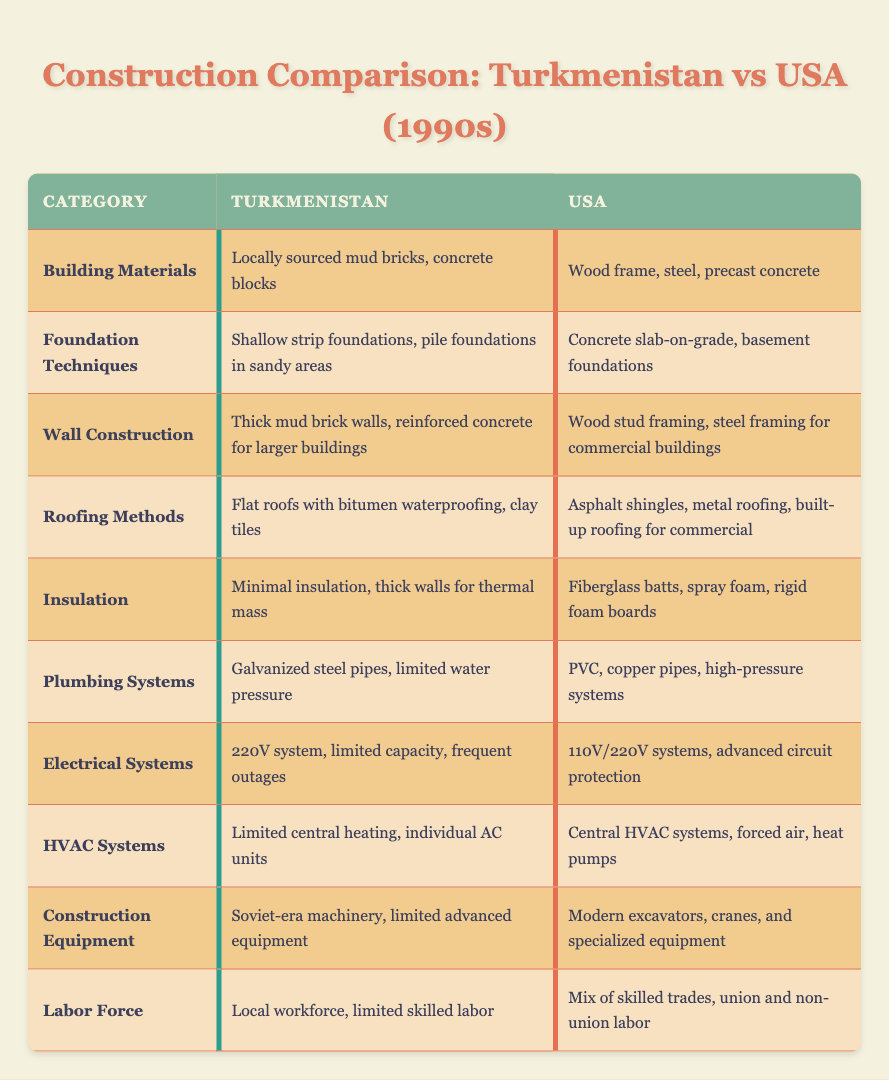What types of building materials are used in Turkmenistan? The table specifies that Turkmenistan uses "Locally sourced mud bricks, concrete blocks" for building materials. This information can be found directly under the "Building Materials" category for Turkmenistan.
Answer: Locally sourced mud bricks, concrete blocks Which foundation technique is commonly used in the USA? The USA employs "Concrete slab-on-grade, basement foundations" as foundation techniques, according to the information in the "Foundation Techniques" category.
Answer: Concrete slab-on-grade, basement foundations Is there a significant difference in plumbing systems between Turkmenistan and the USA? Yes, the table indicates that Turkmenistan uses "Galvanized steel pipes, limited water pressure," while the USA uses "PVC, copper pipes, high-pressure systems," showing clear technology differences in plumbing systems.
Answer: Yes How many categories mention the use of concrete in construction? Reviewing the categories, "Building Materials," "Foundation Techniques," "Wall Construction," and "Roofing Methods" all reference concrete explicitly. Counting these, we see there are four mentions of concrete across different categories.
Answer: 4 What is the main insulation type used in the USA compared to Turkmenistan? In Turkmenistan, the table specifies "Minimal insulation, thick walls for thermal mass" as the insulation method, while in the USA, it uses "Fiberglass batts, spray foam, rigid foam boards." This provides a clear comparison that shows USA employs advanced insulation methods compared to Turkmenistan.
Answer: Fiberglass batts, spray foam, rigid foam boards Which country has more advanced construction equipment? The table states Turkmenistan utilizes "Soviet-era machinery, limited advanced equipment," while the USA employs "Modern excavators, cranes, and specialized equipment." This clearly indicates that the USA has more advanced construction equipment than Turkmenistan.
Answer: USA Is the electrical system in Turkmenistan more or less capable than in the USA? The comparison shows that Turkmenistan has a "220V system, limited capacity, frequent outages," whereas the USA uses "110V/220V systems, advanced circuit protection," indicating that the USA has a more capable electrical system.
Answer: Less capable How does the labor force differ between the two countries? The table notes that Turkmenistan has a "Local workforce, limited skilled labor," compared to the USA's "Mix of skilled trades, union and non-union labor." This demonstrates a notable difference in the availability of skilled labor between the two countries.
Answer: Limited skilled labor in Turkmenistan What roofing methods are used in Turkmenistan versus the USA? Turkmenistan employs "Flat roofs with bitumen waterproofing, clay tiles" while the USA uses "Asphalt shingles, metal roofing, built-up roofing for commercial." This showcases distinct roofing methods in both countries.
Answer: Flat roofs with bitumen; Asphalt shingles, metal roofing 